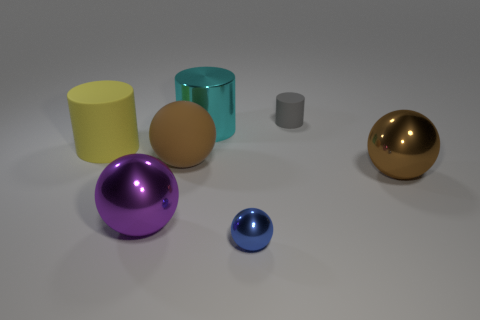Subtract all brown blocks. How many brown spheres are left? 2 Subtract all tiny gray cylinders. How many cylinders are left? 2 Subtract all purple balls. How many balls are left? 3 Add 2 tiny yellow rubber cubes. How many objects exist? 9 Subtract all red cylinders. Subtract all green spheres. How many cylinders are left? 3 Subtract all spheres. How many objects are left? 3 Subtract 0 purple cylinders. How many objects are left? 7 Subtract all cyan cylinders. Subtract all purple metallic objects. How many objects are left? 5 Add 2 big purple metal objects. How many big purple metal objects are left? 3 Add 5 tiny brown matte cylinders. How many tiny brown matte cylinders exist? 5 